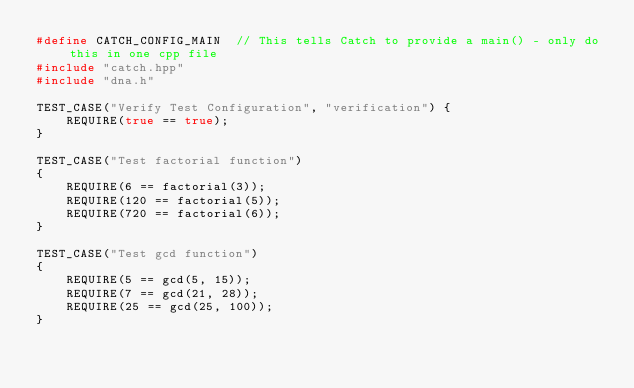Convert code to text. <code><loc_0><loc_0><loc_500><loc_500><_C++_>#define CATCH_CONFIG_MAIN  // This tells Catch to provide a main() - only do this in one cpp file
#include "catch.hpp"
#include "dna.h"

TEST_CASE("Verify Test Configuration", "verification") {
	REQUIRE(true == true);
}

TEST_CASE("Test factorial function")
{
	REQUIRE(6 == factorial(3));
	REQUIRE(120 == factorial(5));
	REQUIRE(720 == factorial(6));
}

TEST_CASE("Test gcd function")
{
	REQUIRE(5 == gcd(5, 15));
	REQUIRE(7 == gcd(21, 28));
	REQUIRE(25 == gcd(25, 100));
}

</code> 